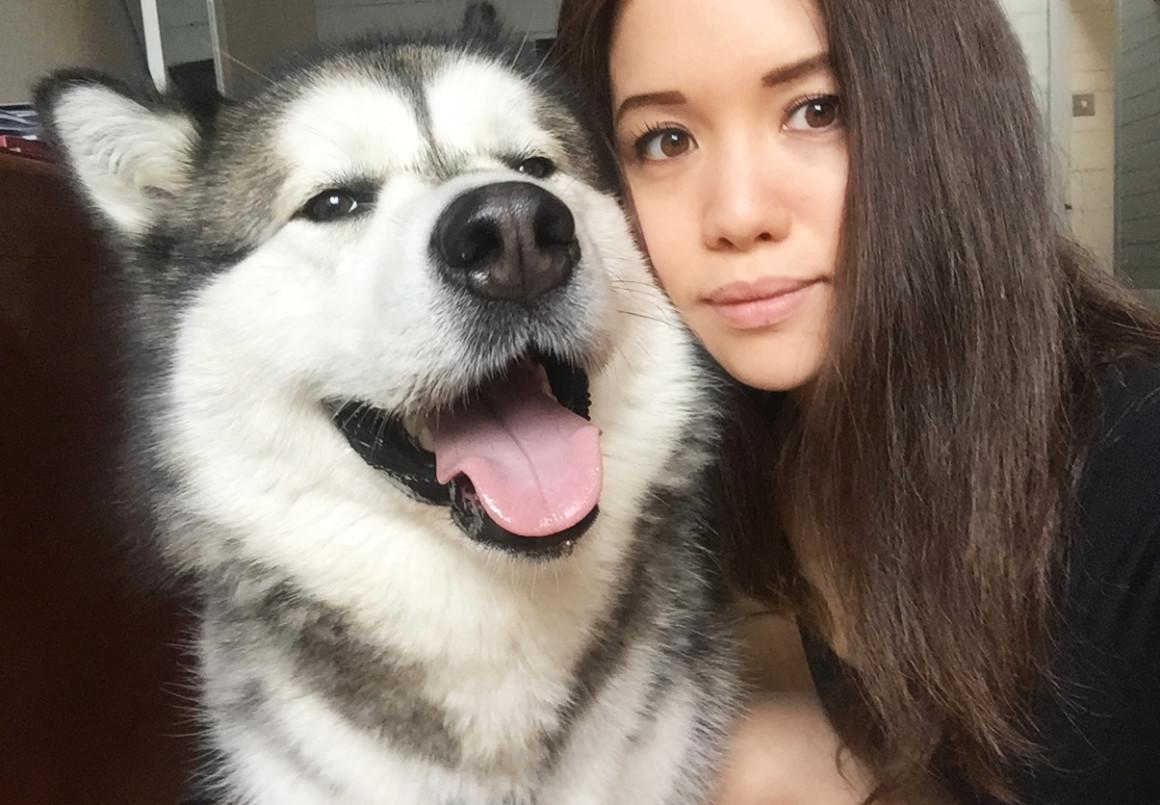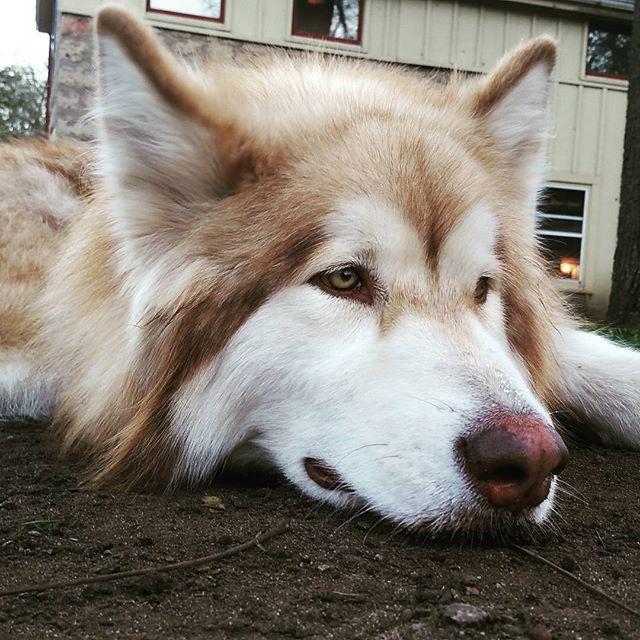The first image is the image on the left, the second image is the image on the right. For the images displayed, is the sentence "The dog in the image on the left is standing up outside." factually correct? Answer yes or no. No. The first image is the image on the left, the second image is the image on the right. For the images displayed, is the sentence "A person wearing black is beside a black-and-white husky in the left image, and the right image shows a reclining dog with white and brown fur." factually correct? Answer yes or no. Yes. 